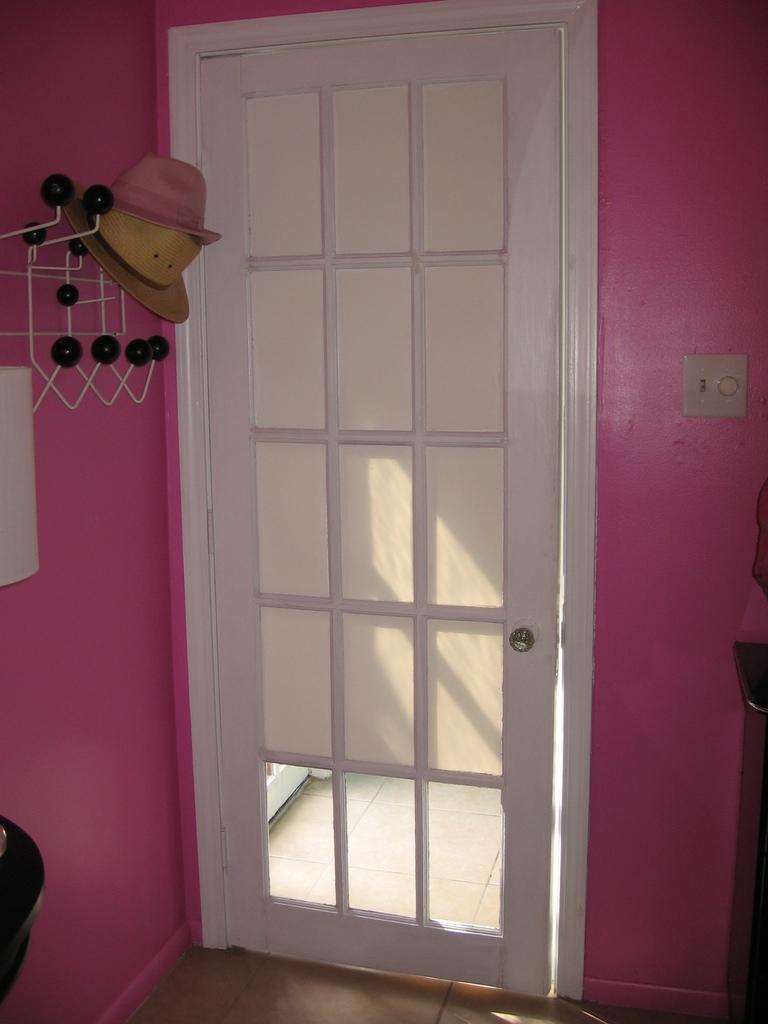Can you describe this image briefly? This picture shows a door and couple of hats on the hanger. The wall is pink in color and the door is white in color. 